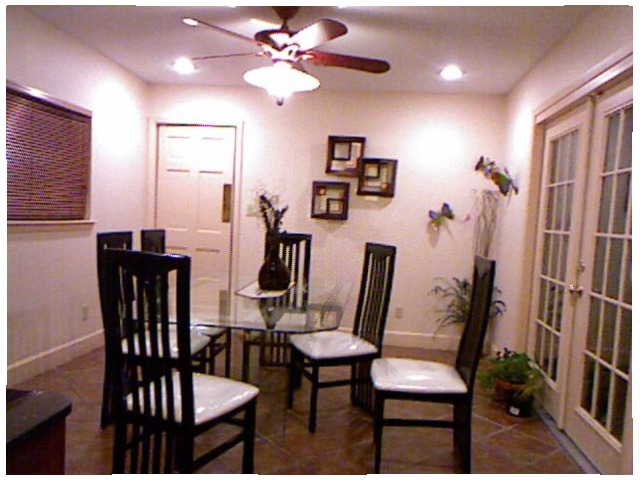<image>
Is there a chair in front of the door? No. The chair is not in front of the door. The spatial positioning shows a different relationship between these objects. 